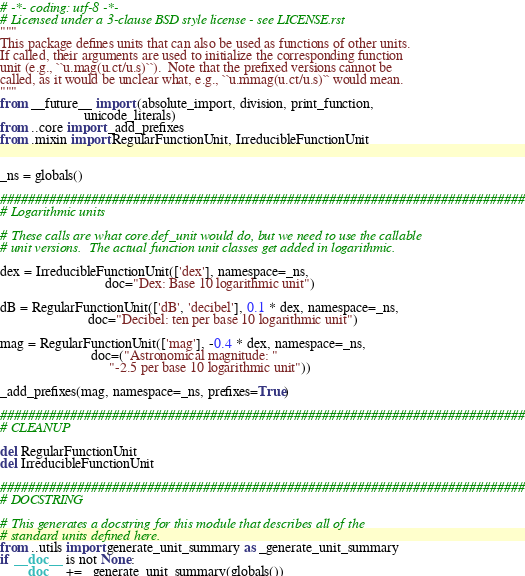<code> <loc_0><loc_0><loc_500><loc_500><_Python_># -*- coding: utf-8 -*-
# Licensed under a 3-clause BSD style license - see LICENSE.rst
"""
This package defines units that can also be used as functions of other units.
If called, their arguments are used to initialize the corresponding function
unit (e.g., ``u.mag(u.ct/u.s)``).  Note that the prefixed versions cannot be
called, as it would be unclear what, e.g., ``u.mmag(u.ct/u.s)`` would mean.
"""
from __future__ import (absolute_import, division, print_function,
                        unicode_literals)
from ..core import _add_prefixes
from .mixin import RegularFunctionUnit, IrreducibleFunctionUnit


_ns = globals()

###########################################################################
# Logarithmic units

# These calls are what core.def_unit would do, but we need to use the callable
# unit versions.  The actual function unit classes get added in logarithmic.

dex = IrreducibleFunctionUnit(['dex'], namespace=_ns,
                              doc="Dex: Base 10 logarithmic unit")

dB = RegularFunctionUnit(['dB', 'decibel'], 0.1 * dex, namespace=_ns,
                         doc="Decibel: ten per base 10 logarithmic unit")

mag = RegularFunctionUnit(['mag'], -0.4 * dex, namespace=_ns,
                          doc=("Astronomical magnitude: "
                               "-2.5 per base 10 logarithmic unit"))

_add_prefixes(mag, namespace=_ns, prefixes=True)

###########################################################################
# CLEANUP

del RegularFunctionUnit
del IrreducibleFunctionUnit

###########################################################################
# DOCSTRING

# This generates a docstring for this module that describes all of the
# standard units defined here.
from ..utils import generate_unit_summary as _generate_unit_summary
if __doc__ is not None:
    __doc__ += _generate_unit_summary(globals())
</code> 